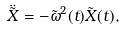Convert formula to latex. <formula><loc_0><loc_0><loc_500><loc_500>\ddot { \tilde { X } } = - \tilde { \omega } ^ { 2 } ( t ) { \tilde { X } } ( t ) ,</formula> 